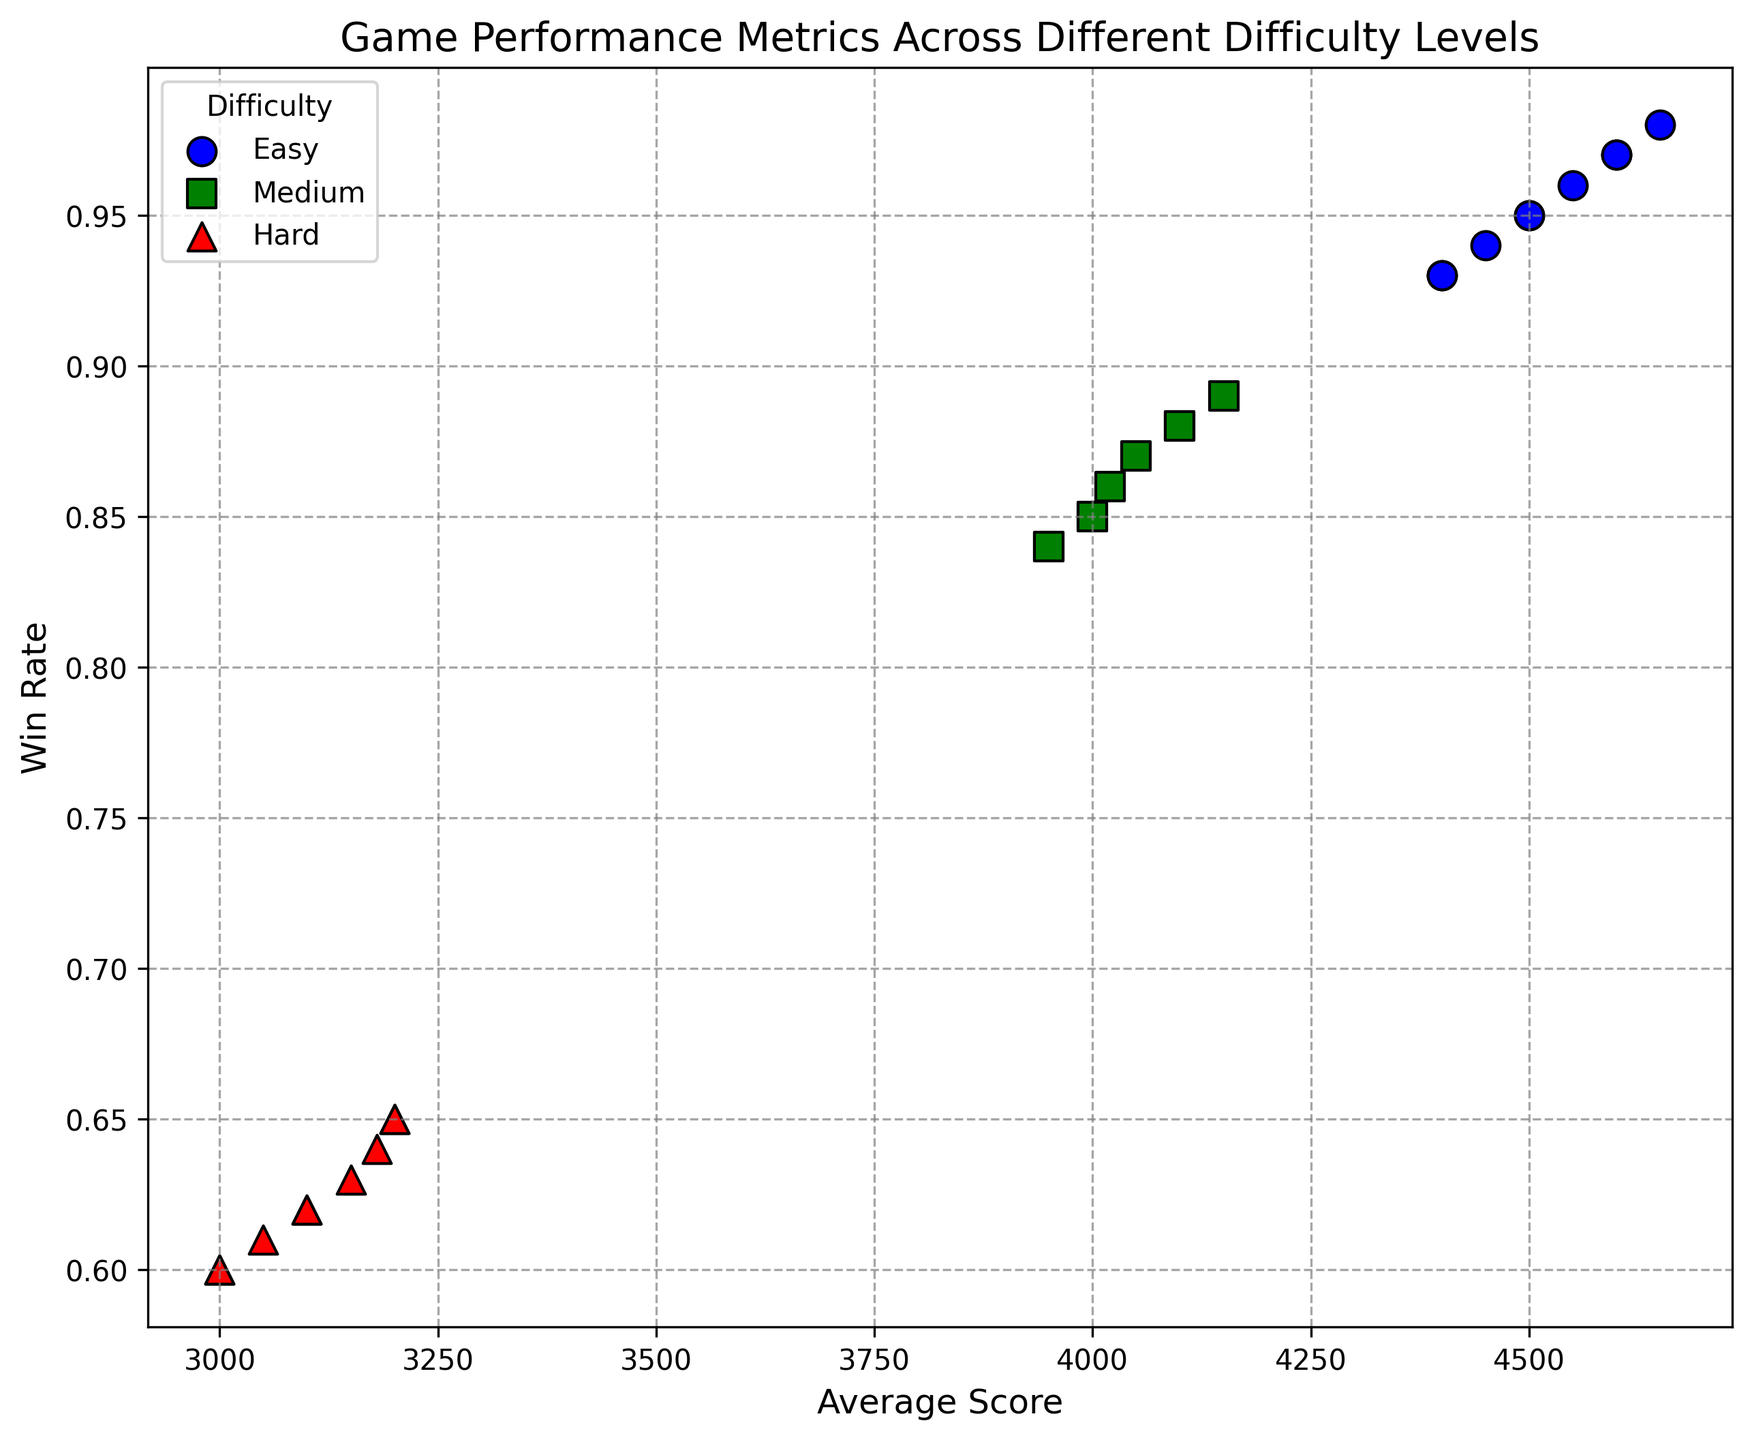How many difficulty levels are depicted in the plot? The legend in the plot shows three different categories, each representing a different difficulty level.
Answer: 3 What is the range of Win Rates for the Easy difficulty level? Observe the scatter plot and note the highest and lowest Win Rate values for markers labeled as Easy (blue circles). The Win Rates range from 0.93 to 0.98.
Answer: 0.93 to 0.98 Which difficulty level has the highest average score? From the scatter plot, the highest average score can be observed by looking at the marker that is the furthest to the right. The blue circles (Easy difficulty) are furthest to the right on the x-axis.
Answer: Easy What is the relationship between Average Score and Win Rate for different difficulty levels? Observe the overall trends in the plot: blue circles (Easy) appear in the top-right, green squares (Medium) are in the middle, and red triangles (Hard) cluster in the bottom-left. This shows a decreasing trend in both Average Score and Win Rate as difficulty increases.
Answer: Negative correlation Which marker color represents the Medium difficulty games? The plot legend shows that Medium difficulty games are represented by green square markers.
Answer: Green What is the difference in Average Score between the highest scoring Easy game and the highest scoring Hard game? The highest Average Score for Easy games is 4650, and for Hard games, it is 3200. The difference is calculated by 4650 - 3200.
Answer: 1450 Comparing all difficulty levels, which one shows the least variance in Win Rate? Look at the spread of markers along the y-axis (Win Rate). The Easy difficulty markers (blue circles) appear to be closest to each other, indicating the smallest variance.
Answer: Easy How does the completion time vary between the easiest and hardest difficulty levels? From the scatter plot, notice that the markers with the shortest Completion Time are blue circles (Easy), and those with the longest are red triangles (Hard). Easy games are around 185-205 units, while Hard games are 330-350 units.
Answer: Increases as difficulty increases Which difficulty level has a player with both the highest Win Rate and highest Average Score? Look for the marker furthest to the top-right corner of the scatter plot. This is the blue circle (Easy difficulty) with a Win Rate of 0.98 and an Average Score of 4650.
Answer: Easy Among the datasets presented, which individual player data point shows the highest completion time and what difficulty is it associated with? The highest Completion Time (y-axis value) can be observed in the scatter plot around 350 units, represented by a red triangle (Hard).
Answer: Hard 